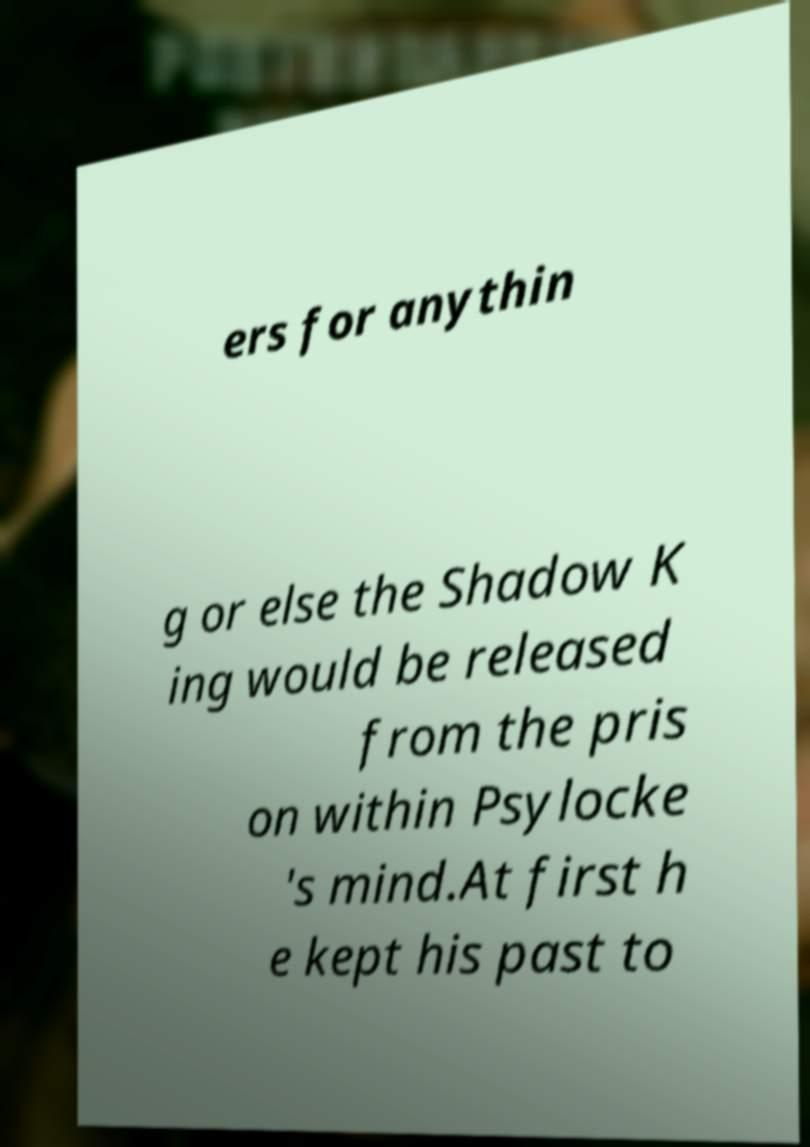Can you read and provide the text displayed in the image?This photo seems to have some interesting text. Can you extract and type it out for me? ers for anythin g or else the Shadow K ing would be released from the pris on within Psylocke 's mind.At first h e kept his past to 